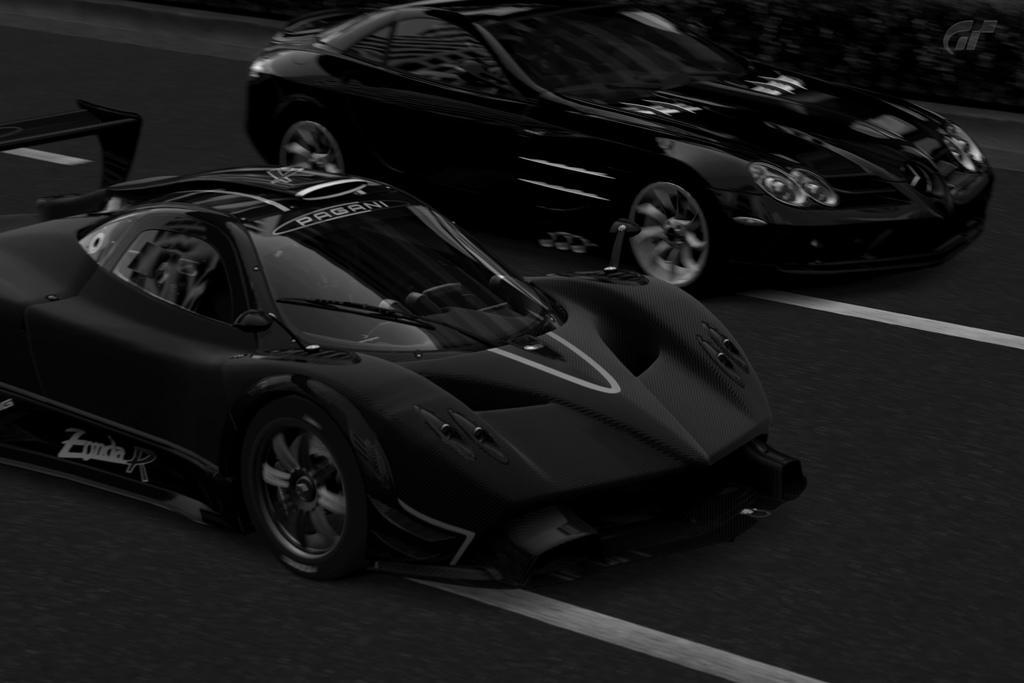Describe this image in one or two sentences. In this picture we can observe two cars on the road. This is a black and white image. 